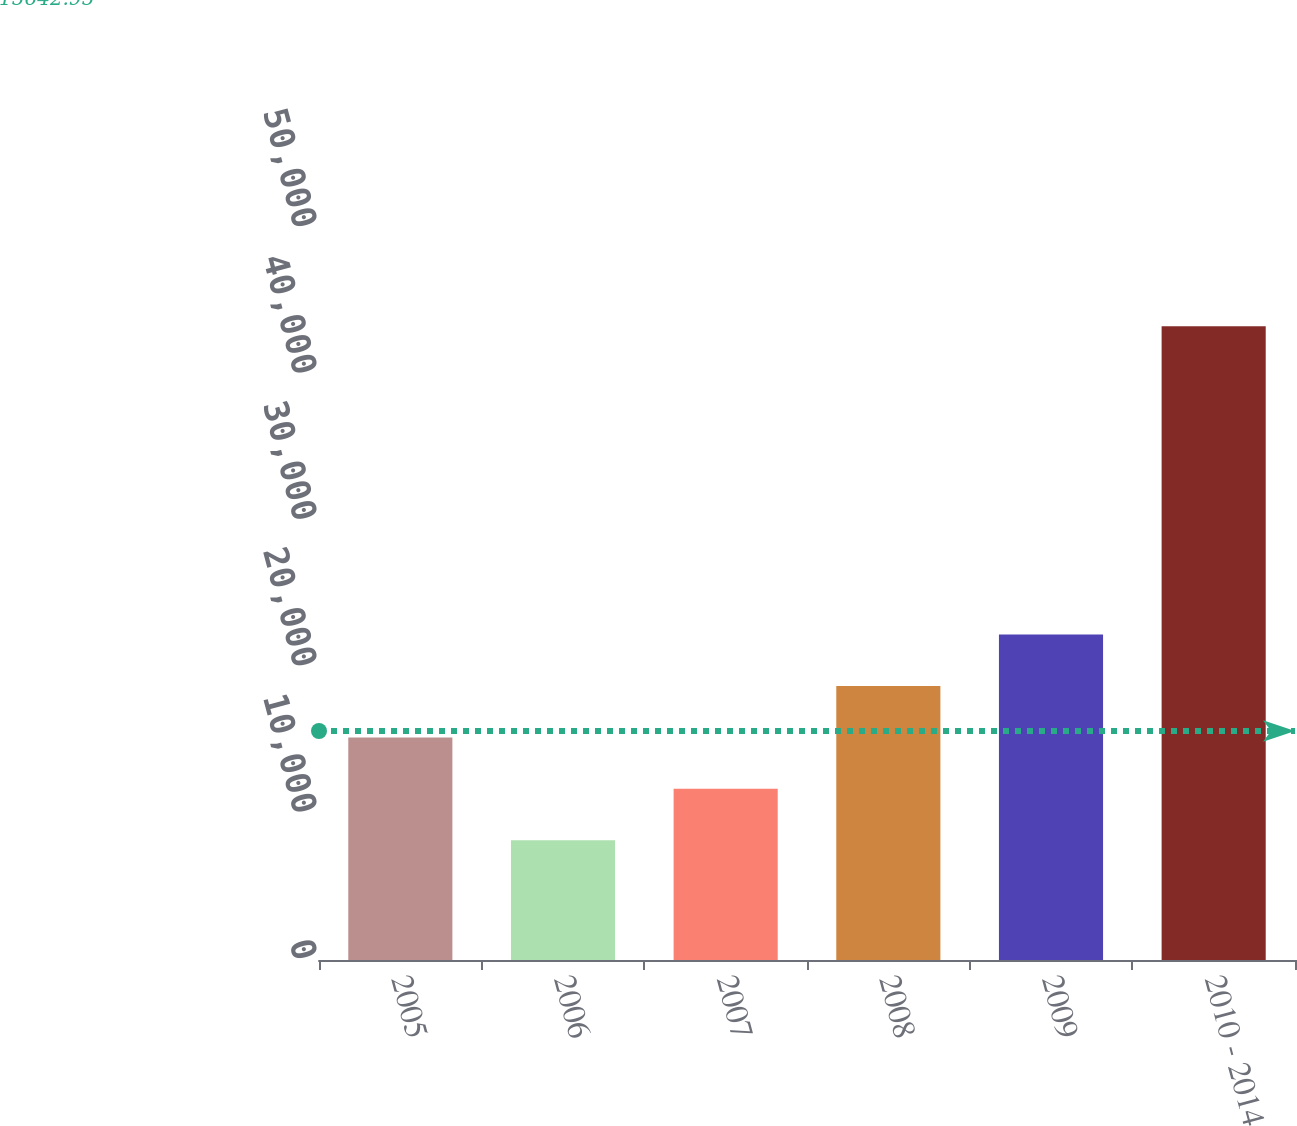Convert chart to OTSL. <chart><loc_0><loc_0><loc_500><loc_500><bar_chart><fcel>2005<fcel>2006<fcel>2007<fcel>2008<fcel>2009<fcel>2010 - 2014<nl><fcel>15205<fcel>8182<fcel>11693.5<fcel>18716.5<fcel>22228<fcel>43297<nl></chart> 